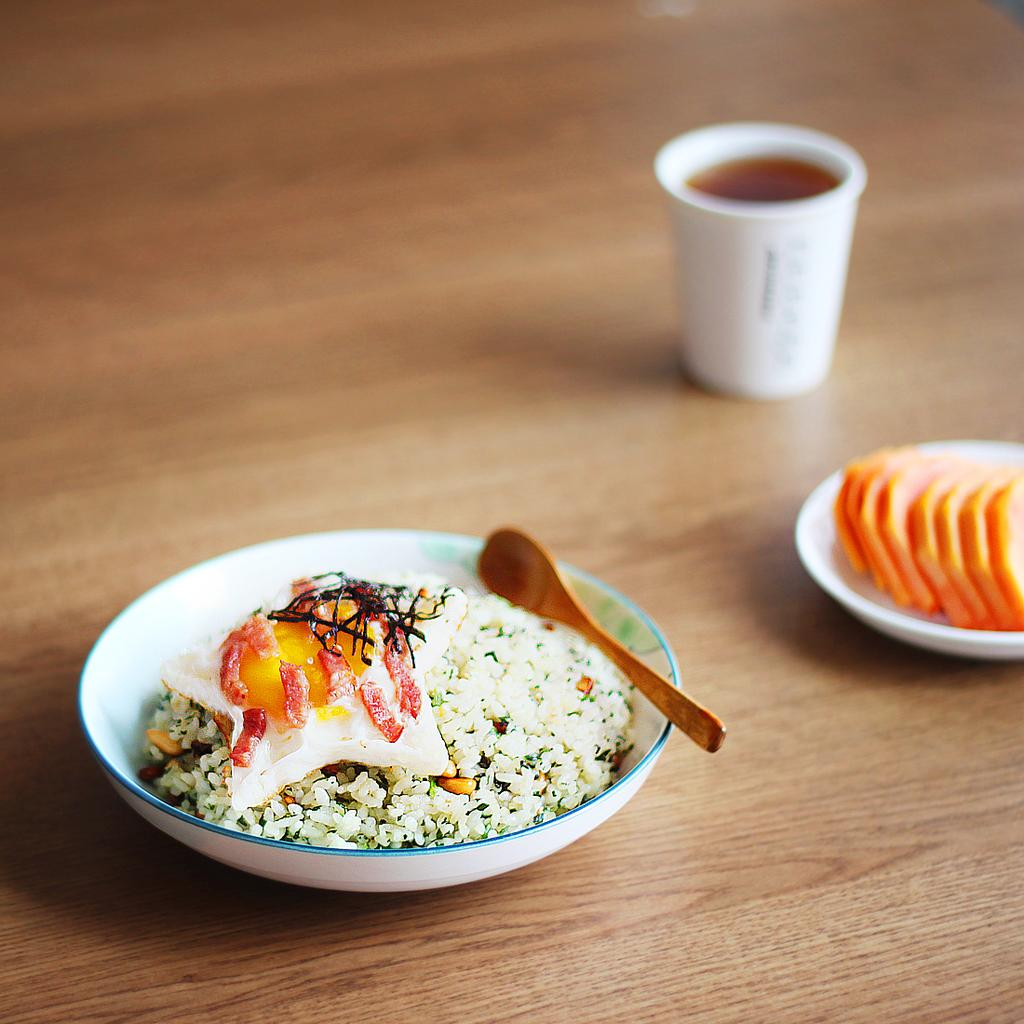What is in the bowl that is in the foreground of the image? There is a bowl with food in the foreground of the image. What utensil is placed with the bowl? There is a spoon on the bowl. What can be seen in the background of the image? In the background, there are cut pieces of fruits in a platter. What else is on the table in the background? There is a cup on the table in the background. How many minutes does it take for the trousers to jump in the image? There are no trousers or jumping actions present in the image. 